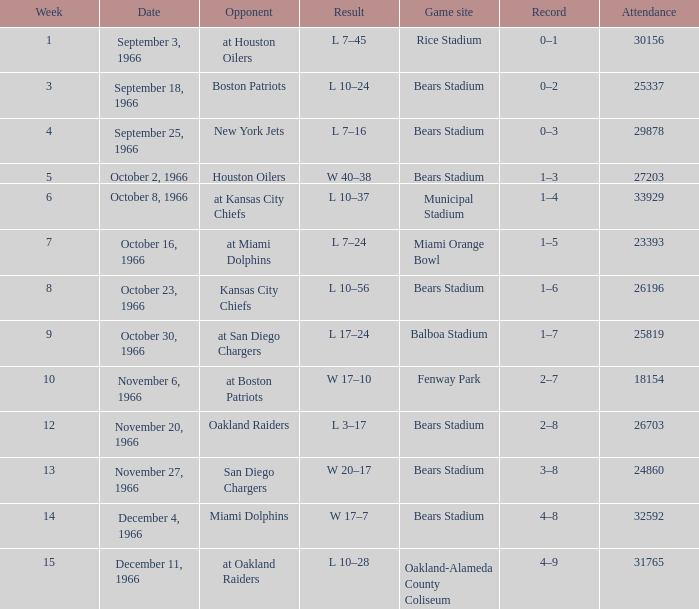How many results are listed for week 13? 1.0. 